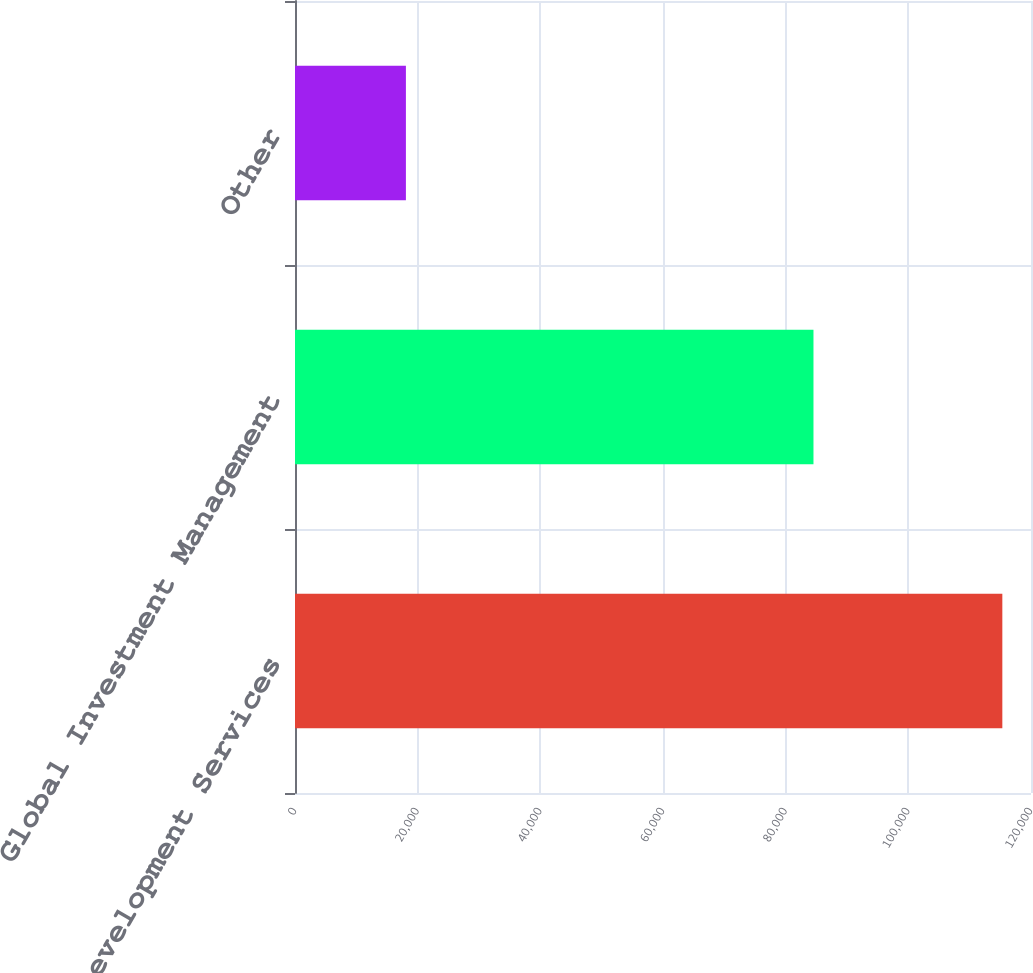<chart> <loc_0><loc_0><loc_500><loc_500><bar_chart><fcel>Development Services<fcel>Global Investment Management<fcel>Other<nl><fcel>115326<fcel>84534<fcel>18083<nl></chart> 